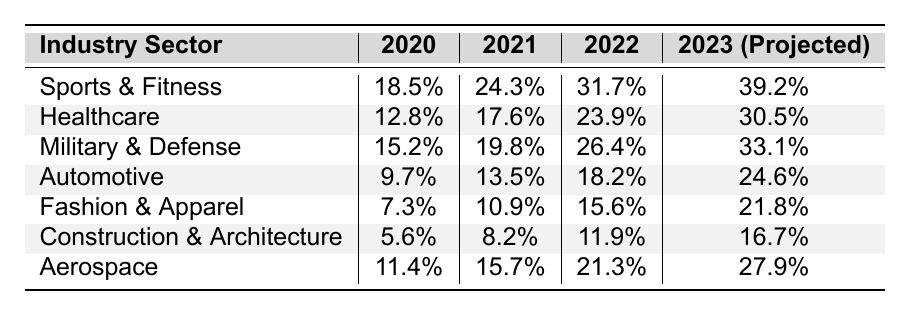What was the adoption rate of smart textiles in the Sports & Fitness sector in 2021? The table shows that the adoption rate in the Sports & Fitness sector was 24.3% in 2021.
Answer: 24.3% Which industry sector had the lowest adoption rate in 2020? Looking at the data for 2020, the Construction & Architecture sector had the lowest adoption rate at 5.6%.
Answer: Construction & Architecture What is the difference in adoption rates for Aerospace from 2020 to 2022? The Aerospace sector had an adoption rate of 11.4% in 2020 and 21.3% in 2022. The difference is 21.3% - 11.4% = 9.9%.
Answer: 9.9% What is the projected adoption rate for the Fashion & Apparel sector in 2023? According to the table, the projected adoption rate for the Fashion & Apparel sector in 2023 is 21.8%.
Answer: 21.8% Which industry sector shows the highest growth rate from 2020 to 2023 (projected)? To determine this, calculate the growth for each sector: Sports & Fitness (20.7%), Healthcare (17.7%), Military & Defense (17.9%), Automotive (14.9%), Fashion & Apparel (14.5%), Construction & Architecture (11.1%), Aerospace (16.5%). The Sports & Fitness sector has the highest growth rate.
Answer: Sports & Fitness Is the adoption rate for Healthcare expected to surpass that of Aerospace in 2023? In 2023, the projected adoption rate for Healthcare is 30.5%, while for Aerospace, it is 27.9%. Therefore, Healthcare will surpass Aerospace.
Answer: Yes What is the average adoption rate of smart textiles across all sectors in 2022? The adoption rates in 2022 are as follows: Sports & Fitness (31.7%), Healthcare (23.9%), Military & Defense (26.4%), Automotive (18.2%), Fashion & Apparel (15.6%), Construction & Architecture (11.9%), Aerospace (21.3%). Adding these gives 31.7 + 23.9 + 26.4 + 18.2 + 15.6 + 11.9 + 21.3 = 148.1%, and dividing by 7 sectors gives an average of 148.1/7 ≈ 21.16%.
Answer: 21.16% In which year did the Military & Defense sector have an adoption rate equal to or greater than 25%? Evaluating the table, the Military & Defense sector reached an adoption rate of 26.4% in 2022. In 2021, it was 19.8%, which is less than 25%. Therefore, 2022 was the first year to exceed that threshold.
Answer: 2022 Did the adoption rate of smart textiles in Automotive increase every year from 2020 to 2023? The data shows that the adoption rates for Automotive increased from 9.7% in 2020 to 13.5% in 2021, to 18.2% in 2022, and projected to be 24.6% in 2023. Therefore, it increased every year.
Answer: Yes What percentage of the projected adoption rate for 2023 does the Healthcare sector represent in comparison to the Sports & Fitness sector? The projected adoption rates for 2023 are 30.5% for Healthcare and 39.2% for Sports & Fitness. To find the percentage: (30.5% / 39.2%) * 100 ≈ 77.8%.
Answer: 77.8% 